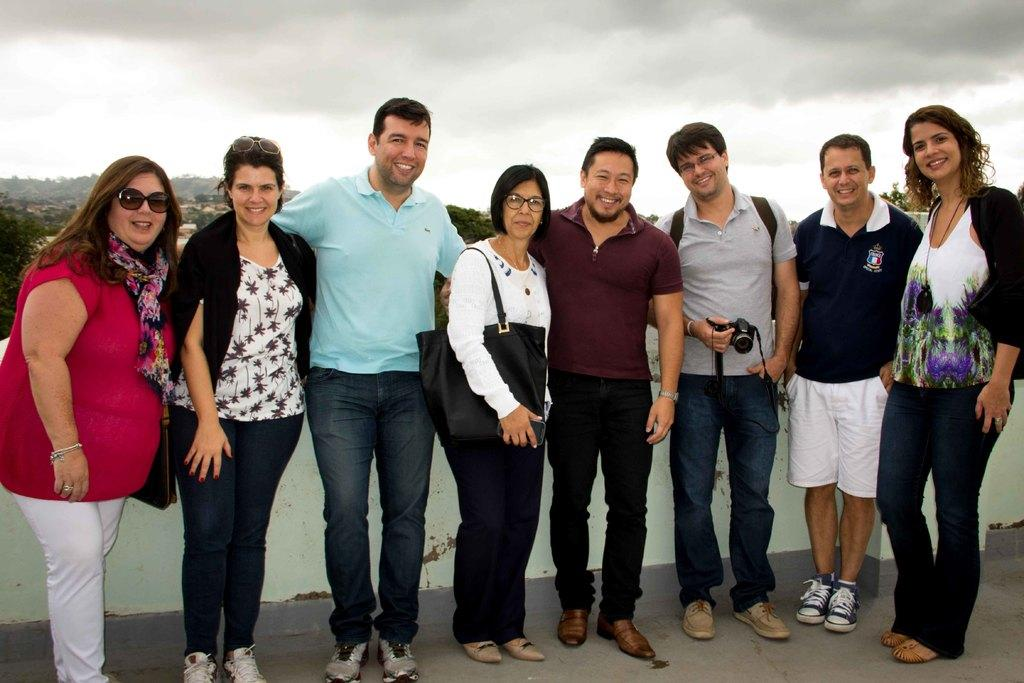What are the people in the image doing? The people in the image are standing and smiling. Can you describe the woman's attire in the image? The woman is wearing a bag. What is the man holding in the image? The man is holding a camera. What can be seen in the background of the image? There is a wall, trees, and the sky visible in the background of the image. What is the condition of the sky in the image? The sky is visible in the background of the image, and clouds are present. Can you tell me how many snakes are slithering around the woman's feet in the image? There are no snakes present in the image; the woman is wearing a bag and standing with other people. What type of dinosaur can be seen roaming in the background of the image? There are no dinosaurs present in the image; the background features a wall, trees, and the sky with clouds. 